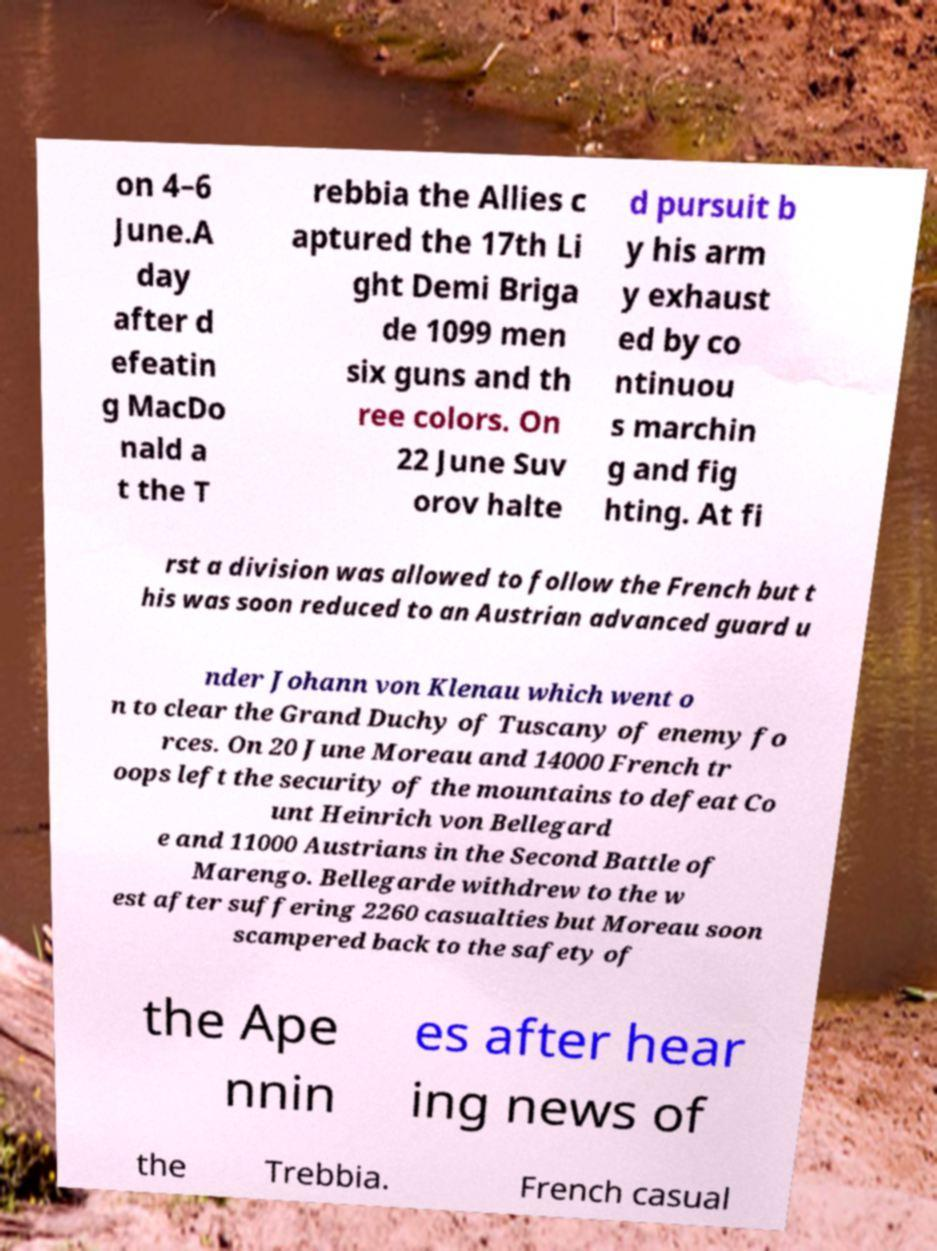For documentation purposes, I need the text within this image transcribed. Could you provide that? on 4–6 June.A day after d efeatin g MacDo nald a t the T rebbia the Allies c aptured the 17th Li ght Demi Briga de 1099 men six guns and th ree colors. On 22 June Suv orov halte d pursuit b y his arm y exhaust ed by co ntinuou s marchin g and fig hting. At fi rst a division was allowed to follow the French but t his was soon reduced to an Austrian advanced guard u nder Johann von Klenau which went o n to clear the Grand Duchy of Tuscany of enemy fo rces. On 20 June Moreau and 14000 French tr oops left the security of the mountains to defeat Co unt Heinrich von Bellegard e and 11000 Austrians in the Second Battle of Marengo. Bellegarde withdrew to the w est after suffering 2260 casualties but Moreau soon scampered back to the safety of the Ape nnin es after hear ing news of the Trebbia. French casual 